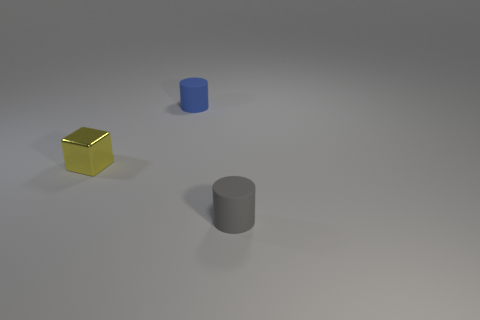There is a small blue object that is the same material as the small gray cylinder; what is its shape?
Offer a terse response. Cylinder. How many objects are both on the left side of the gray rubber cylinder and right of the yellow shiny block?
Make the answer very short. 1. Is there any other thing that has the same shape as the small metallic thing?
Ensure brevity in your answer.  No. How big is the rubber thing that is behind the yellow metallic block?
Your answer should be very brief. Small. How many other objects are there of the same color as the metal cube?
Ensure brevity in your answer.  0. What is the thing that is on the left side of the object behind the yellow object made of?
Make the answer very short. Metal. There is a tiny rubber cylinder behind the small yellow shiny object; is its color the same as the small shiny cube?
Your answer should be very brief. No. Is there any other thing that is the same material as the yellow block?
Your answer should be very brief. No. How many other blue matte objects are the same shape as the small blue object?
Offer a very short reply. 0. What size is the blue object that is made of the same material as the small gray thing?
Offer a very short reply. Small. 